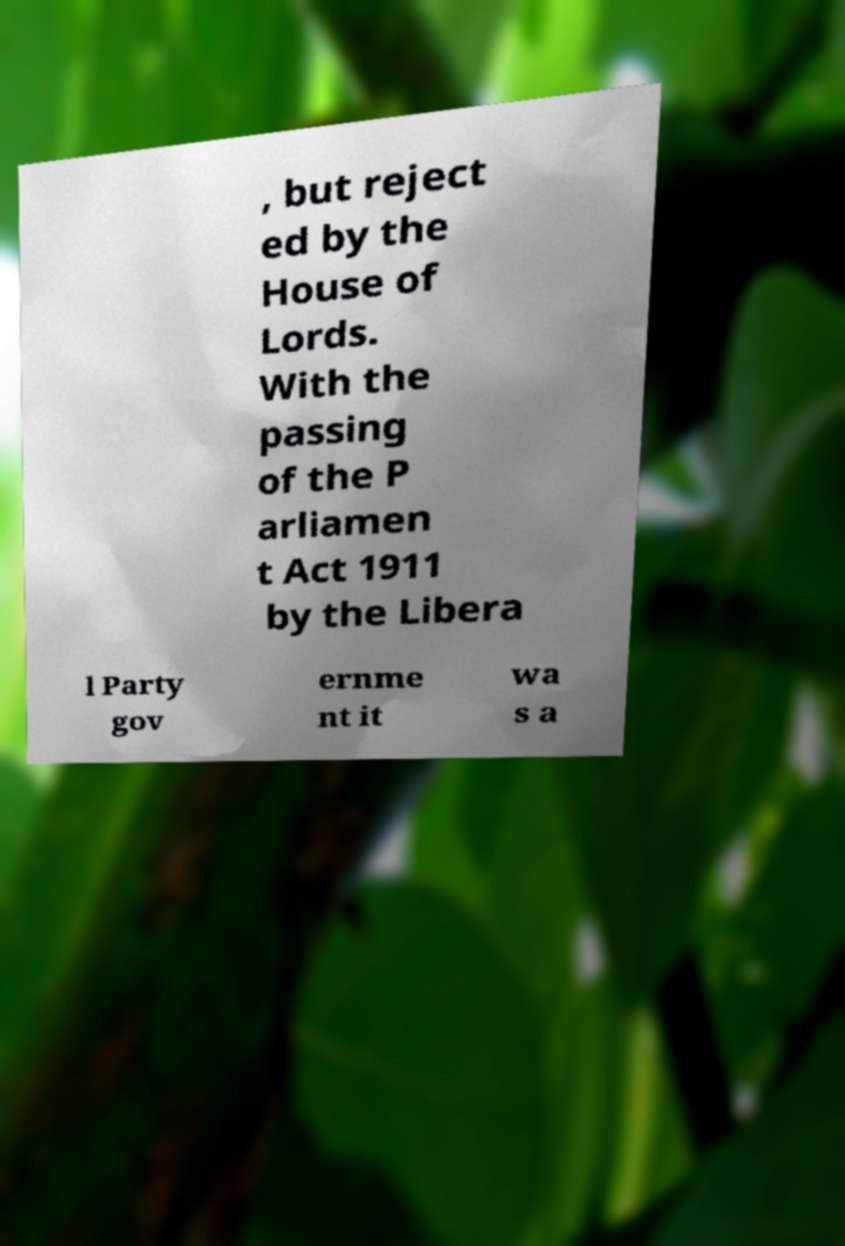Please read and relay the text visible in this image. What does it say? , but reject ed by the House of Lords. With the passing of the P arliamen t Act 1911 by the Libera l Party gov ernme nt it wa s a 